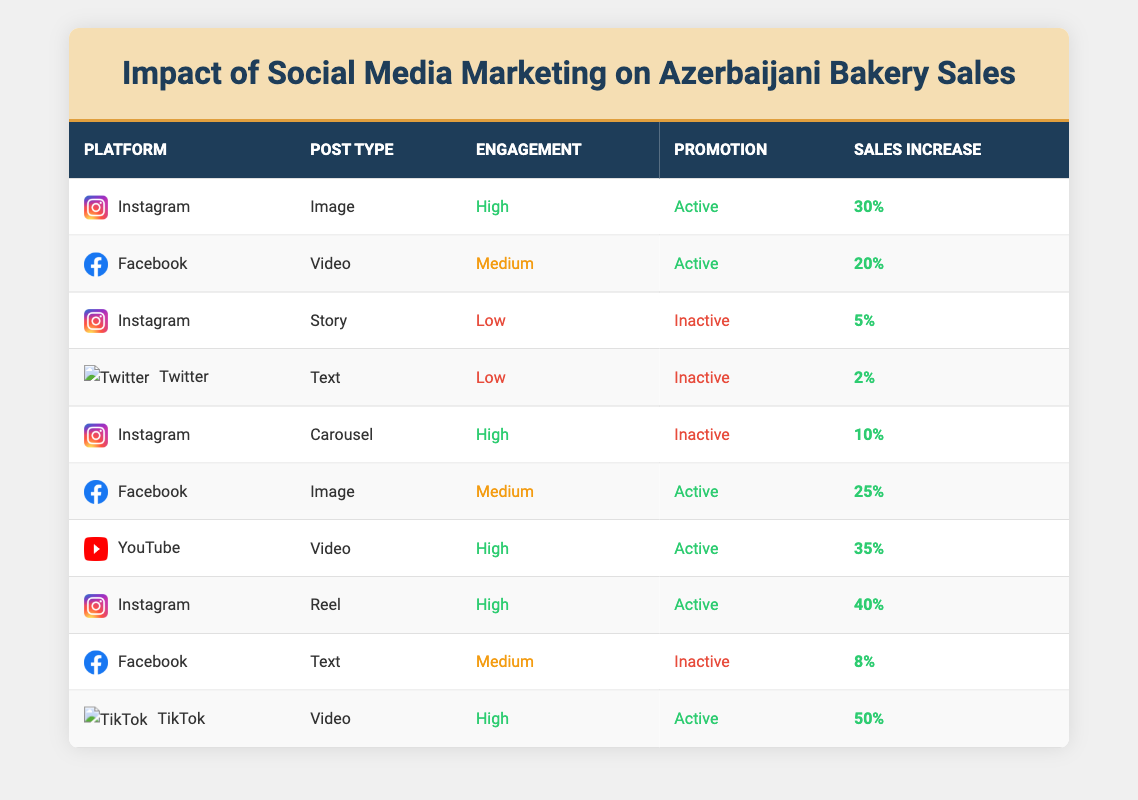What is the sales increase percentage for a video post on TikTok? By looking at the table, I find TikTok listed under the "SocialMediaPlatform" column. It has a "PostType" of "Video" with a "SalesIncreasePercentage" of 50%.
Answer: 50% Which platform has the highest sales increase percentage and what is that percentage? By reviewing the table, I see that TikTok has the highest sales increase percentage of 50%.
Answer: TikTok, 50% How many social media posts are categorized as "High" engagement? I can identify the rows where "EngagementLevel" is "High". Examining the table, I see five instances (Instagram Image, Instagram Carousel, YouTube Video, Instagram Reel, TikTok Video).
Answer: 5 What is the average sales increase percentage for active promoted posts? To find the average, I need to sum the sales increase percentages of the active posts, which are: 30% (Instagram Image), 20% (Facebook Video), 25% (Facebook Image), 35% (YouTube Video), 40% (Instagram Reel), and 50% (TikTok Video). Adding these gives 30 + 20 + 25 + 35 + 40 + 50 = 200%. There are six active posts, so I divide 200% by 6 for an average of approximately 33.33%.
Answer: 33.33% Is there any post with "Low" engagement that has an "Active" promotion status? Checking the table, I look for rows with "Low" engagement and "Active" promotion. There are no entries that meet both criteria.
Answer: No Which platform has the lowest sales increase percentage and what is that percentage? By analyzing the sales increase percentages, I find that Twitter has the lowest increase at 2%.
Answer: Twitter, 2% How many posts contributed to a sales increase of 20% or more? I retrieve each sales increase percentage and see that the following posts contribute to 20% or more: Instagram Image (30%), Facebook Video (20%), Facebook Image (25%), YouTube Video (35%), Instagram Reel (40%), and TikTok Video (50%). That's a total of six posts.
Answer: 6 What is the percentage difference in sales increase between a "High" engagement post with "Active" promotion and a "Low" engagement post with "Inactive" promotion? The highest "High" engagement with "Active" promotion is from the TikTok Video at 50%. The "Low" engagement post that is "Inactive" is from Twitter at 2%. The percentage difference is calculated as 50 - 2 = 48%.
Answer: 48% 